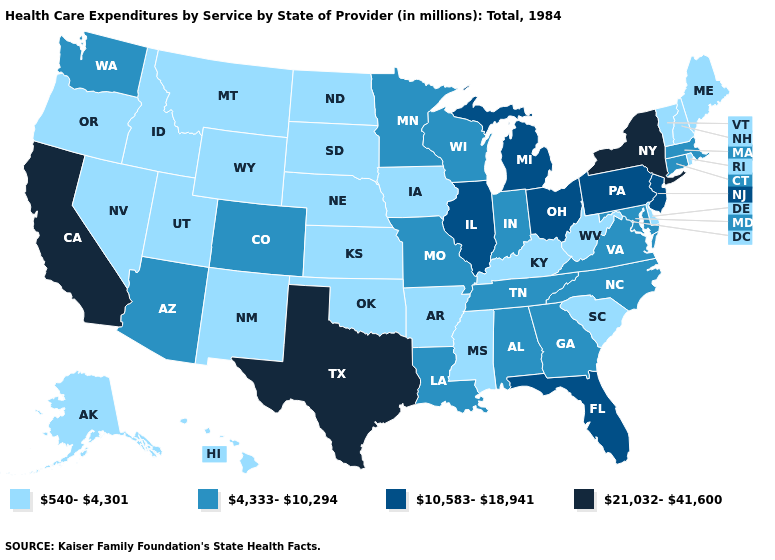What is the value of Pennsylvania?
Write a very short answer. 10,583-18,941. Name the states that have a value in the range 540-4,301?
Concise answer only. Alaska, Arkansas, Delaware, Hawaii, Idaho, Iowa, Kansas, Kentucky, Maine, Mississippi, Montana, Nebraska, Nevada, New Hampshire, New Mexico, North Dakota, Oklahoma, Oregon, Rhode Island, South Carolina, South Dakota, Utah, Vermont, West Virginia, Wyoming. Name the states that have a value in the range 10,583-18,941?
Answer briefly. Florida, Illinois, Michigan, New Jersey, Ohio, Pennsylvania. What is the lowest value in the MidWest?
Be succinct. 540-4,301. What is the highest value in the MidWest ?
Answer briefly. 10,583-18,941. Name the states that have a value in the range 540-4,301?
Concise answer only. Alaska, Arkansas, Delaware, Hawaii, Idaho, Iowa, Kansas, Kentucky, Maine, Mississippi, Montana, Nebraska, Nevada, New Hampshire, New Mexico, North Dakota, Oklahoma, Oregon, Rhode Island, South Carolina, South Dakota, Utah, Vermont, West Virginia, Wyoming. Does Colorado have the same value as West Virginia?
Quick response, please. No. Name the states that have a value in the range 10,583-18,941?
Write a very short answer. Florida, Illinois, Michigan, New Jersey, Ohio, Pennsylvania. Does the map have missing data?
Concise answer only. No. Does Texas have the highest value in the USA?
Be succinct. Yes. Name the states that have a value in the range 540-4,301?
Be succinct. Alaska, Arkansas, Delaware, Hawaii, Idaho, Iowa, Kansas, Kentucky, Maine, Mississippi, Montana, Nebraska, Nevada, New Hampshire, New Mexico, North Dakota, Oklahoma, Oregon, Rhode Island, South Carolina, South Dakota, Utah, Vermont, West Virginia, Wyoming. What is the highest value in states that border New Jersey?
Be succinct. 21,032-41,600. What is the lowest value in the MidWest?
Keep it brief. 540-4,301. Name the states that have a value in the range 10,583-18,941?
Concise answer only. Florida, Illinois, Michigan, New Jersey, Ohio, Pennsylvania. What is the lowest value in states that border Tennessee?
Write a very short answer. 540-4,301. 